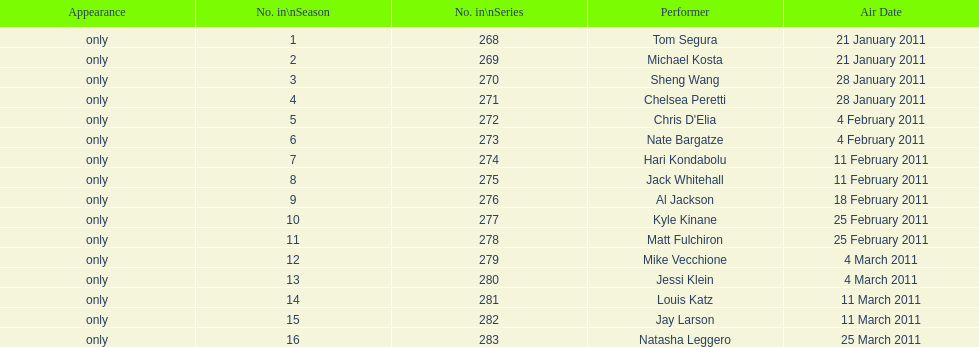Which month had the most air dates? February. 